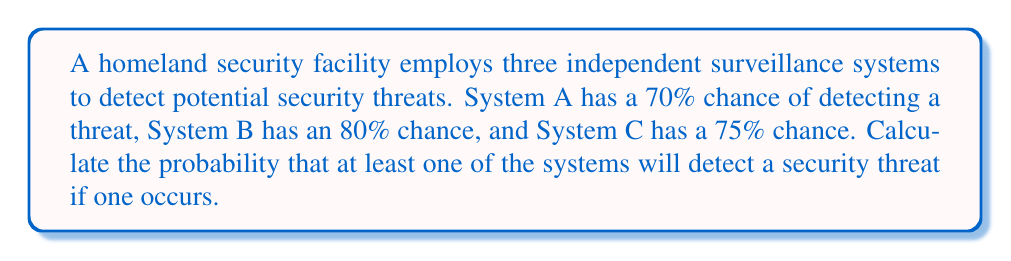Show me your answer to this math problem. To solve this problem, we'll use the concept of probability of independent events and the complement rule.

1. First, let's define the probabilities:
   $P(A) = 0.70$ (probability of System A detecting a threat)
   $P(B) = 0.80$ (probability of System B detecting a threat)
   $P(C) = 0.75$ (probability of System C detecting a threat)

2. We want to find the probability that at least one system detects the threat. It's easier to calculate the probability that none of the systems detect the threat and then subtract this from 1.

3. The probability that System A fails to detect the threat is:
   $P(\text{not A}) = 1 - P(A) = 1 - 0.70 = 0.30$

4. Similarly for Systems B and C:
   $P(\text{not B}) = 1 - P(B) = 1 - 0.80 = 0.20$
   $P(\text{not C}) = 1 - P(C) = 1 - 0.75 = 0.25$

5. Since the systems are independent, the probability that all systems fail to detect the threat is the product of their individual failure probabilities:
   $P(\text{none detect}) = P(\text{not A}) \times P(\text{not B}) \times P(\text{not C})$
   $P(\text{none detect}) = 0.30 \times 0.20 \times 0.25 = 0.015$

6. Therefore, the probability that at least one system detects the threat is:
   $P(\text{at least one detects}) = 1 - P(\text{none detect})$
   $P(\text{at least one detects}) = 1 - 0.015 = 0.985$

7. Convert to a percentage:
   $0.985 \times 100\% = 98.5\%$
Answer: The probability that at least one of the surveillance systems will detect a security threat if one occurs is $98.5\%$. 